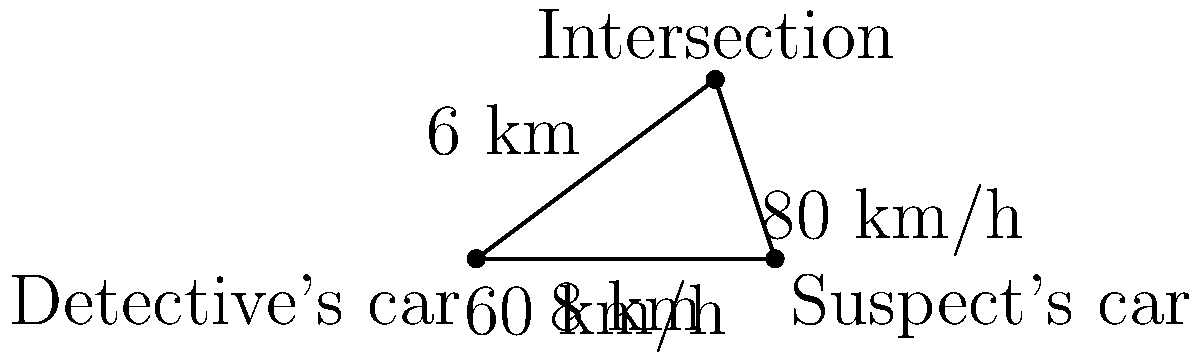In your latest mystery novel, a high-speed chase scene is crucial to the plot. A detective's car travels north at 60 km/h, while a suspect's car heads northeast at 80 km/h. If they start 10 km apart on the same road, how long will it take for their paths to intersect, and how far north of the starting point will this occur? Let's approach this step-by-step:

1) First, we need to break down the northeast direction of the suspect's car into its north and east components.
   - North component: $80 \cos 45° = 80 \cdot \frac{\sqrt{2}}{2} \approx 56.57$ km/h
   - East component: $80 \sin 45° = 80 \cdot \frac{\sqrt{2}}{2} \approx 56.57$ km/h

2) Now, we can set up equations for the distance traveled north by each car:
   - Detective's car: $d_1 = 60t$
   - Suspect's car: $d_2 = 56.57t$

3) The east distance traveled by the suspect's car will be equal to the initial separation when they meet:
   $56.57t = 10$

4) Solving for t:
   $t = \frac{10}{56.57} \approx 0.1768$ hours or about 10.61 minutes

5) Now we can find the north distance traveled by the detective's car:
   $d_1 = 60 \cdot 0.1768 = 10.61$ km

Therefore, it will take approximately 10.61 minutes for their paths to intersect, and this will occur about 10.61 km north of the starting point.
Answer: 10.61 minutes; 10.61 km north 